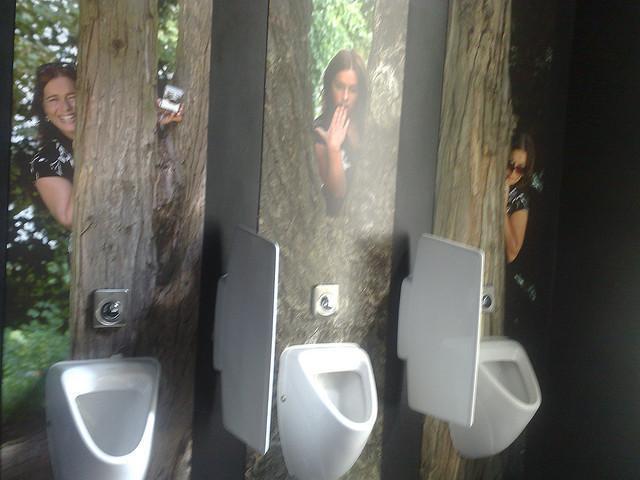How many toilets are there?
Give a very brief answer. 3. How many people are there?
Give a very brief answer. 3. How many cakes are present?
Give a very brief answer. 0. 